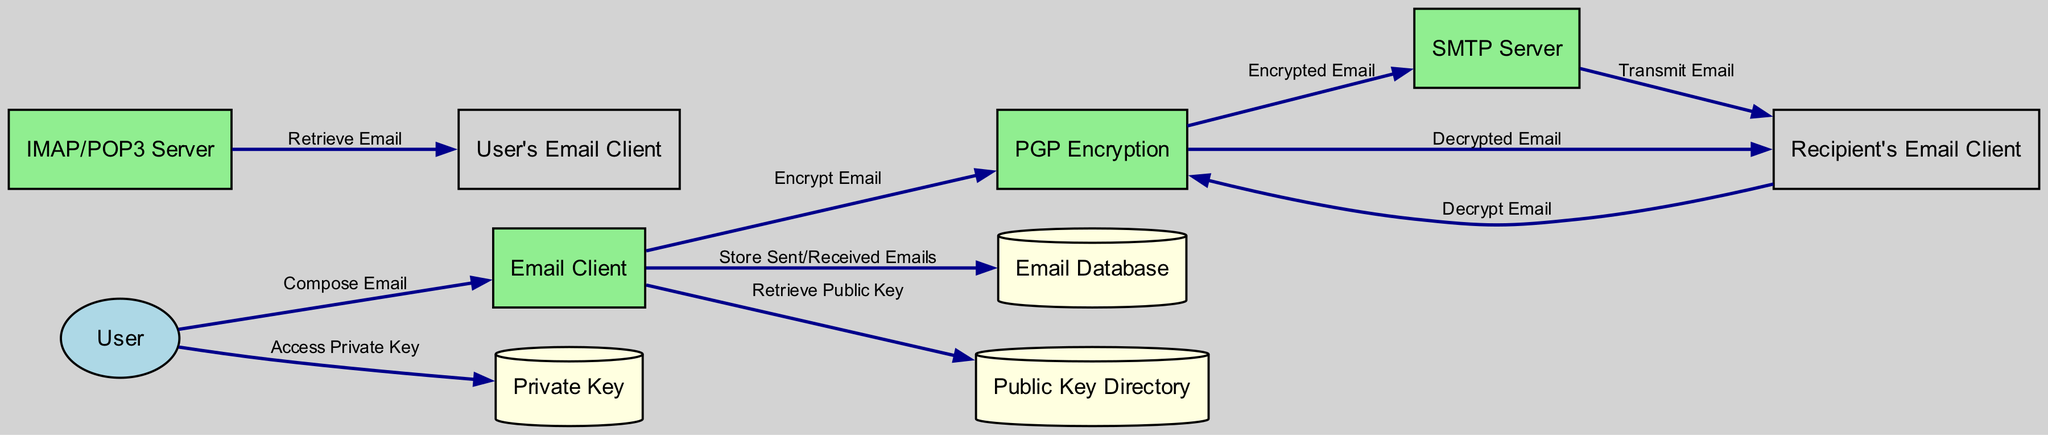What are the total number of entities in the diagram? The diagram lists the entities under the "entities" section. There are eight entities: User, Email Client, SMTP Server, IMAP/POP3 Server, PGP Encryption, Email Database, Private Key, and Public Key Directory, which sums up to a total of eight.
Answer: 8 Which email protocol is used for sending emails? The data flow from the PGP Encryption to the SMTP Server indicates that the SMTP Server is responsible for sending emails. SMTP stands for Simple Mail Transfer Protocol, which is explicitly mentioned in the description of that process.
Answer: SMTP Server What does the recipient's email client do with the encrypted email? According to the data flow from the Recipient's Email Client to PGP Encryption, it demonstrates the action of decrypting the email using the recipient's private key. This process involves taking the encrypted email and decrypting it, which is specifically stated in the flow.
Answer: Decrypt Email How many data stores are present in the diagram? The diagram identifies three data stores: Email Database, Private Key, and Public Key Directory. By counting these distinct nodes, we find that there is a total of three data stores.
Answer: 3 What action does the email client perform after sending or receiving emails? The flow from Email Client to Email Database indicates that the email client stores both sent and received emails in the local database. This action is crucial for record-keeping and retrieval of correspondence.
Answer: Store Sent/Received Emails What type of key does the user access for decrypting received emails? The data flow from User to Private Key states that the user accesses their private key for the purpose of decrypting emails. This implies that the private key is critical for the encryption-decryption process in secure email communication.
Answer: Private Key Which server is responsible for retrieving emails? The flow from IMAP/POP3 Server to User’s Email Client indicates that this server retrieves emails. The IMAP (Internet Message Access Protocol) or POP3 (Post Office Protocol) servers are explicitly designed for this function mentioned in the corresponding description.
Answer: IMAP/POP3 Server What does the email client retrieve from the public key directory? According to the flow from Email Client to Public Key Directory, the email client retrieves the recipient's public key, which is crucial for encrypting the email prior to sending it. This key helps ensure the secure transmission of the email content.
Answer: Retrieve Public Key 